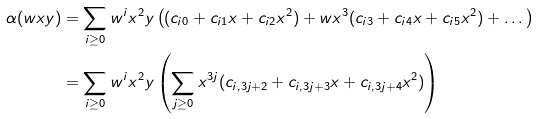<formula> <loc_0><loc_0><loc_500><loc_500>\alpha ( w x y ) & = \sum _ { i \geq 0 } w ^ { i } x ^ { 2 } y \left ( ( c _ { i 0 } + c _ { i 1 } x + c _ { i 2 } x ^ { 2 } ) + w x ^ { 3 } ( c _ { i 3 } + c _ { i 4 } x + c _ { i 5 } x ^ { 2 } ) + \dots \right ) \\ & = \sum _ { i \geq 0 } w ^ { i } x ^ { 2 } y \left ( \sum _ { j \geq 0 } x ^ { 3 j } ( c _ { i , 3 j + 2 } + c _ { i , 3 j + 3 } x + c _ { i , 3 j + 4 } x ^ { 2 } ) \right )</formula> 